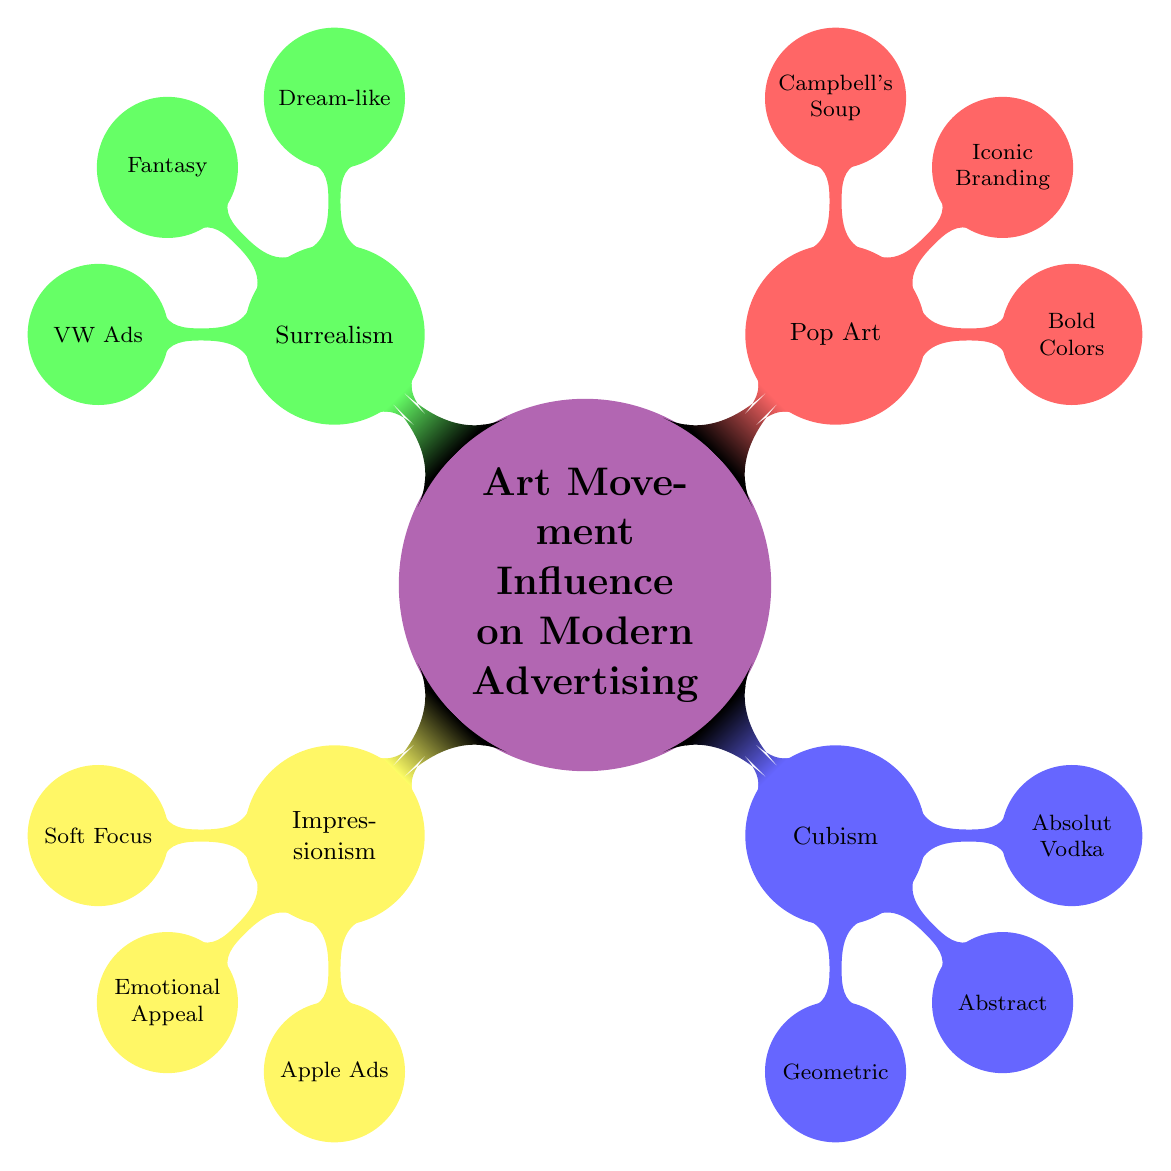What art movement is associated with "Soft Focus"? The diagram shows that "Soft Focus" is a child node under the "Impressionism" parent node, indicating that this characteristic belongs to the Impressionist art movement.
Answer: Impressionism How many examples are listed under "Surrealism"? By examining the "Surrealism" node, we see that it has three child nodes: "Dream-like," "Fantasy," and "VW Ads." Thus, the total number of examples listed under Surrealism is one.
Answer: 1 Which movement emphasizes "Geometric Shapes"? The diagram explicitly indicates that "Geometric Shapes" is a characteristic listed under the "Cubism" node, revealing that this movement is associated with this feature.
Answer: Cubism What characteristic is related to "Iconic Branding"? The diagram indicates that "Iconic Branding" is an influence stemming from the "Pop Art" movement, showing the connection between the characteristic and the art movement.
Answer: Pop Art How are advertisements from Absolut Vodka categorized in the diagram? The diagram categorizes Absolut Vodka’s ads under the "Cubism" node, indicating they are inspired by concepts from the Cubist art movement, specifically the influences outlined there.
Answer: Cubism Which advertisement example is linked to "Emotional Appeal"? Looking at the "Emotional Appeal" child node under "Impressionism," the diagram associates this influence with examples including "Apple’s ‘Shot on iPhone’ Campaign."
Answer: Apple’s ‘Shot on iPhone’ Campaign Which art movement utilizes "Fantasy Elements"? The node labeled "Fantasy Elements" is a child of the "Surrealism" node, demonstrating that surrealist art incorporates fantasy aspects in modern advertising.
Answer: Surrealism What is the overall theme of the mind map? The central node of the mind map is "Art Movement Influence on Modern Advertising," suggesting that the entire diagram illustrates how various art movements impact modern advertising techniques and styles.
Answer: Art Movement Influence on Modern Advertising 